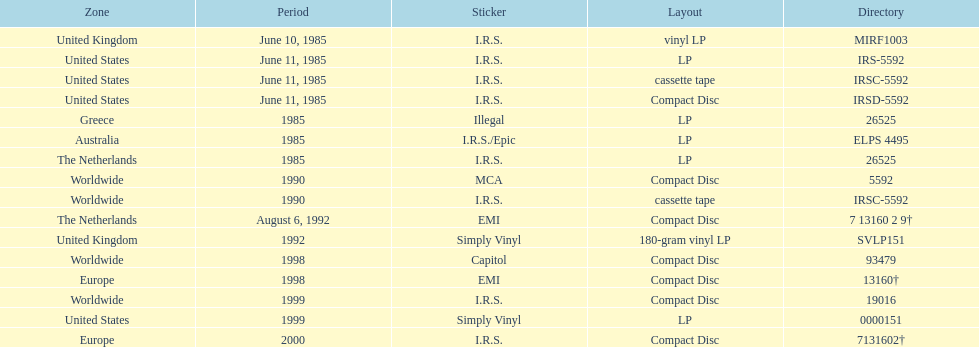What is the greatest consecutive amount of releases in lp format? 3. 